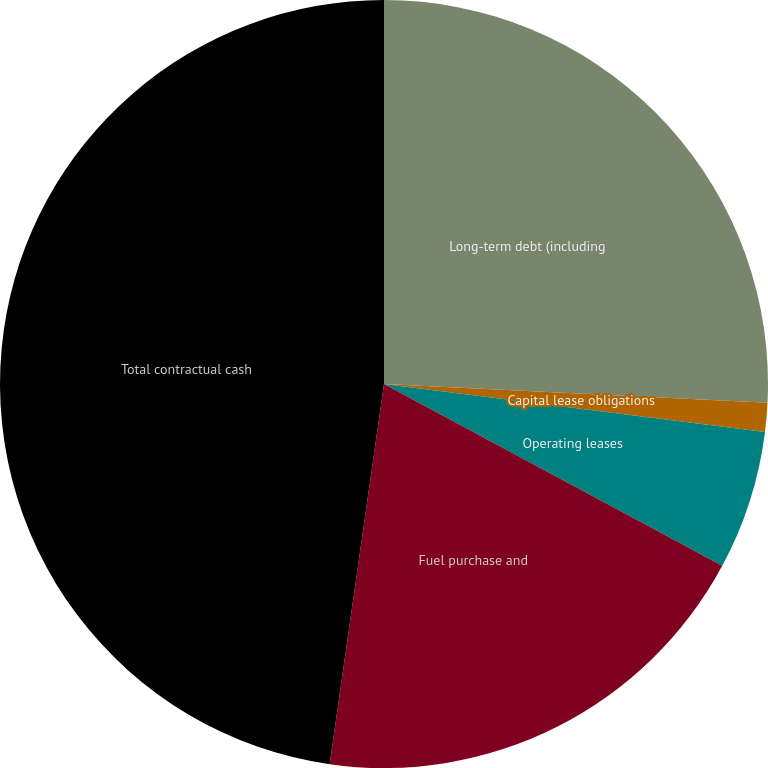<chart> <loc_0><loc_0><loc_500><loc_500><pie_chart><fcel>Long-term debt (including<fcel>Capital lease obligations<fcel>Operating leases<fcel>Fuel purchase and<fcel>Total contractual cash<nl><fcel>25.78%<fcel>1.21%<fcel>5.86%<fcel>19.41%<fcel>47.74%<nl></chart> 